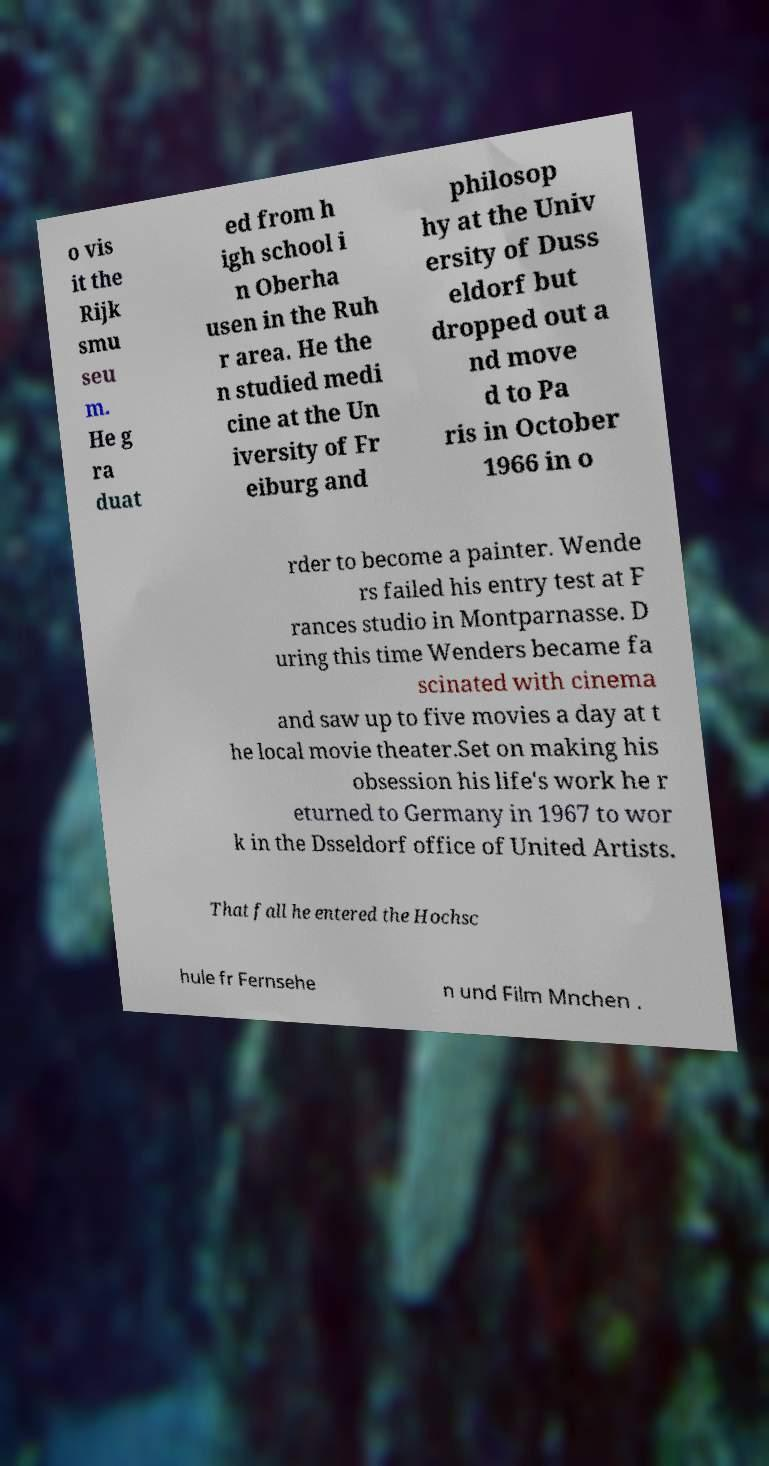What messages or text are displayed in this image? I need them in a readable, typed format. o vis it the Rijk smu seu m. He g ra duat ed from h igh school i n Oberha usen in the Ruh r area. He the n studied medi cine at the Un iversity of Fr eiburg and philosop hy at the Univ ersity of Duss eldorf but dropped out a nd move d to Pa ris in October 1966 in o rder to become a painter. Wende rs failed his entry test at F rances studio in Montparnasse. D uring this time Wenders became fa scinated with cinema and saw up to five movies a day at t he local movie theater.Set on making his obsession his life's work he r eturned to Germany in 1967 to wor k in the Dsseldorf office of United Artists. That fall he entered the Hochsc hule fr Fernsehe n und Film Mnchen . 